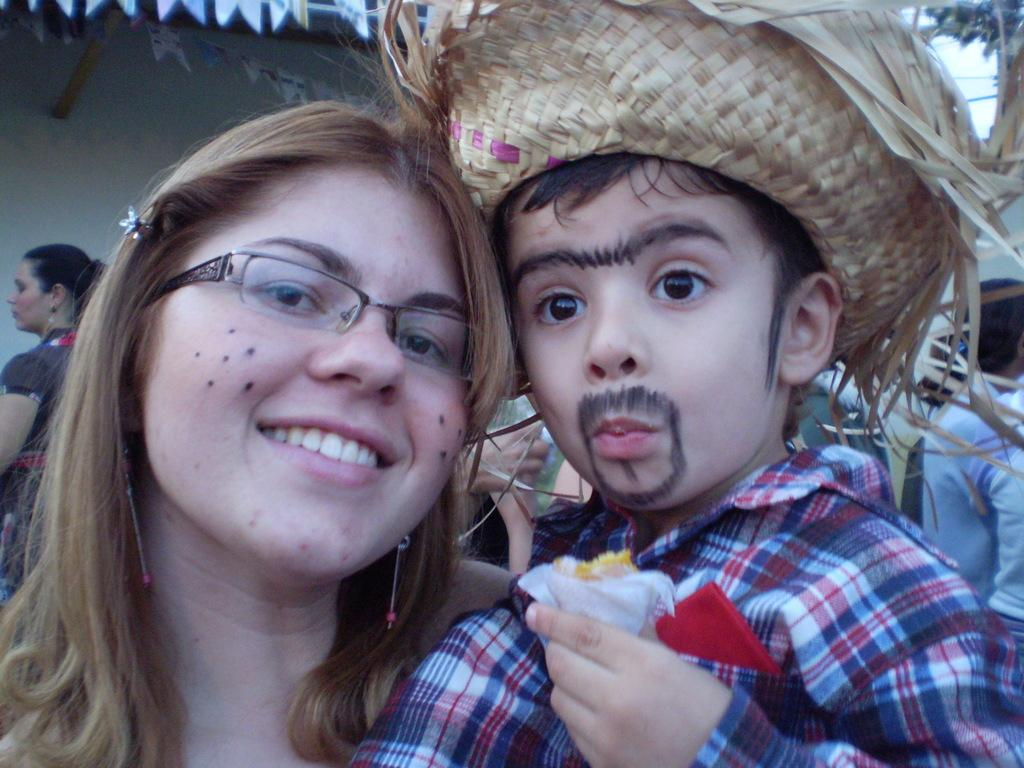Who are the main subjects in the foreground of the picture? There is a woman and a kid in the foreground of the picture. What can be seen in the background of the picture? There are people and a well in the background of the picture. What type of worm can be seen crawling out of the basin in the image? There is no worm or basin present in the image. 